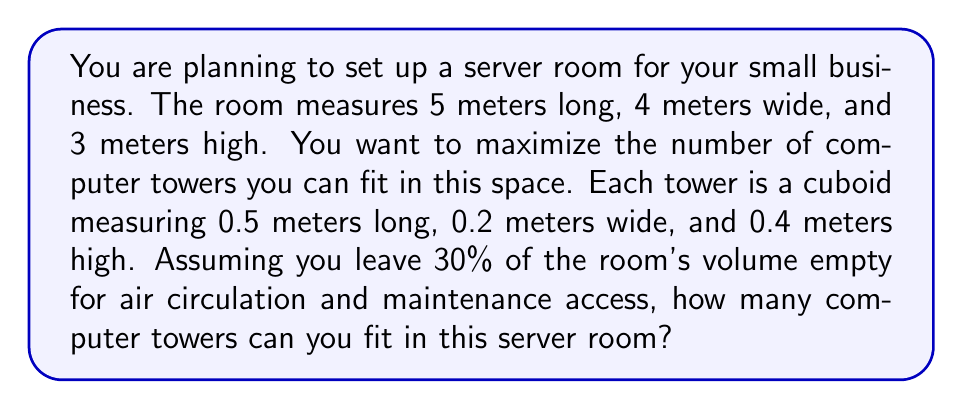Show me your answer to this math problem. Let's approach this problem step by step:

1. Calculate the total volume of the room:
   $$V_{room} = 5m \times 4m \times 3m = 60m^3$$

2. Calculate the usable volume (70% of the total volume):
   $$V_{usable} = 60m^3 \times 0.7 = 42m^3$$

3. Calculate the volume of each computer tower:
   $$V_{tower} = 0.5m \times 0.2m \times 0.4m = 0.04m^3$$

4. Calculate the number of towers that can fit in the usable space:
   $$N_{towers} = \frac{V_{usable}}{V_{tower}} = \frac{42m^3}{0.04m^3} = 1050$$

However, we need to round down to the nearest whole number, as we can't have a fraction of a tower.

Therefore, the maximum number of computer towers that can fit in the server room is 1050.

[asy]
import three;

size(200);
currentprojection=perspective(6,3,2);

// Room
draw(box((0,0,0),(5,4,3)),rgb(0.8,0.8,0.8)+opacity(0.2));

// Tower
draw(shift((0,0,0))*scale(0.5,0.2,0.4)*unitcube,blue+opacity(0.5));

// Labels
label("5m",(2.5,4,0),S);
label("4m",(5,2,0),E);
label("3m",(5,4,1.5),NE);
label("0.5m",(0.25,0,0),S,fontsize(8));
label("0.2m",(0.5,0.1,0),E,fontsize(8));
label("0.4m",(0.5,0,0.2),NE,fontsize(8));
[/asy]
Answer: 1050 computer towers 